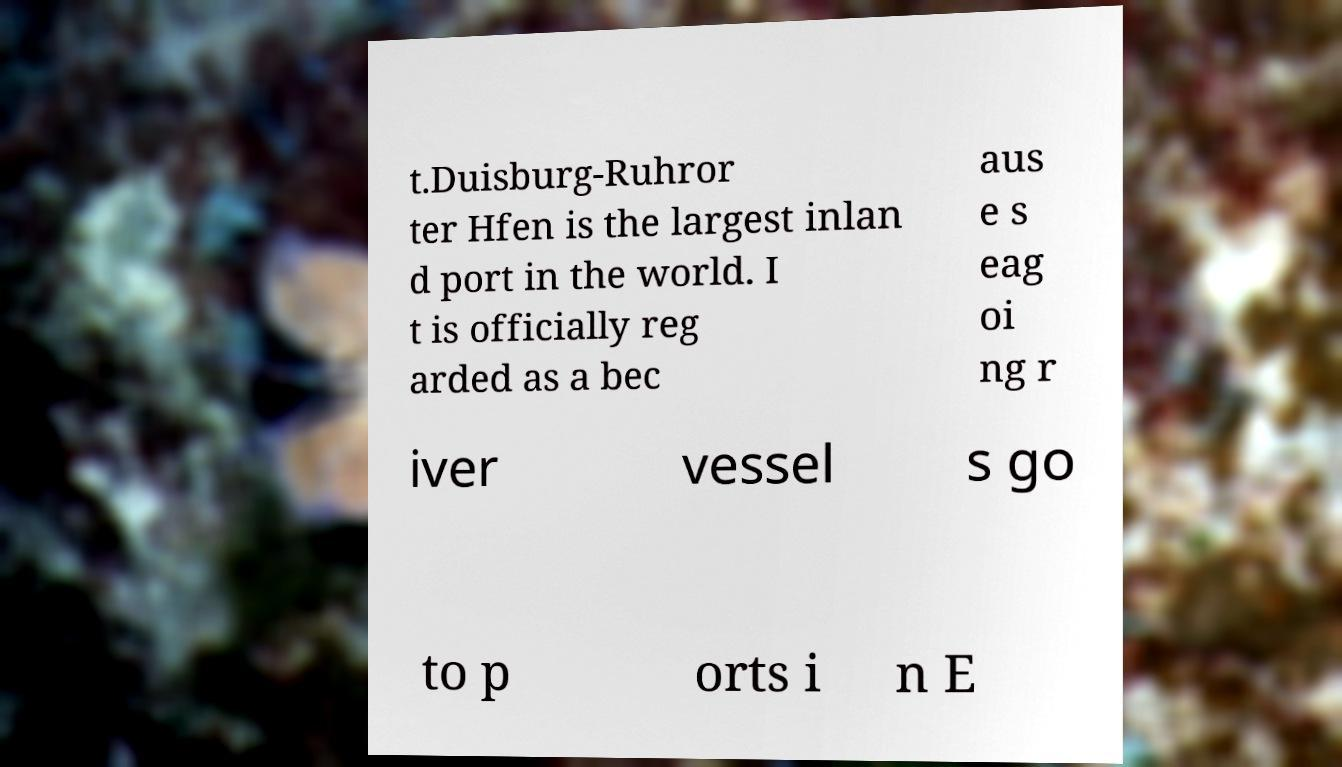What messages or text are displayed in this image? I need them in a readable, typed format. t.Duisburg-Ruhror ter Hfen is the largest inlan d port in the world. I t is officially reg arded as a bec aus e s eag oi ng r iver vessel s go to p orts i n E 